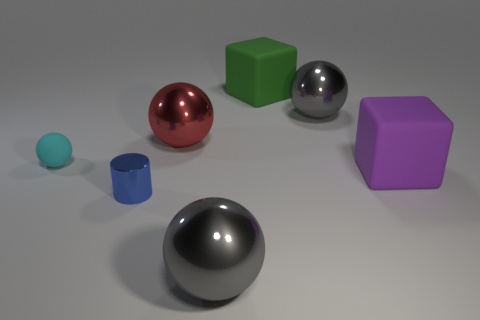The small rubber thing has what color?
Offer a terse response. Cyan. Are any small cyan matte spheres visible?
Keep it short and to the point. Yes. Are there any shiny spheres to the right of the purple rubber object?
Provide a short and direct response. No. What material is the big green object that is the same shape as the purple matte object?
Keep it short and to the point. Rubber. Is there anything else that has the same material as the blue cylinder?
Keep it short and to the point. Yes. What number of other things are there of the same shape as the small blue object?
Keep it short and to the point. 0. How many blue metal objects are to the left of the gray metal thing that is right of the large shiny object in front of the small blue metallic thing?
Your answer should be compact. 1. How many purple things are the same shape as the big green rubber thing?
Provide a succinct answer. 1. There is a ball that is in front of the cyan matte object; is its color the same as the matte sphere?
Your response must be concise. No. The small object to the left of the small object that is in front of the matte ball on the left side of the green thing is what shape?
Your answer should be compact. Sphere. 